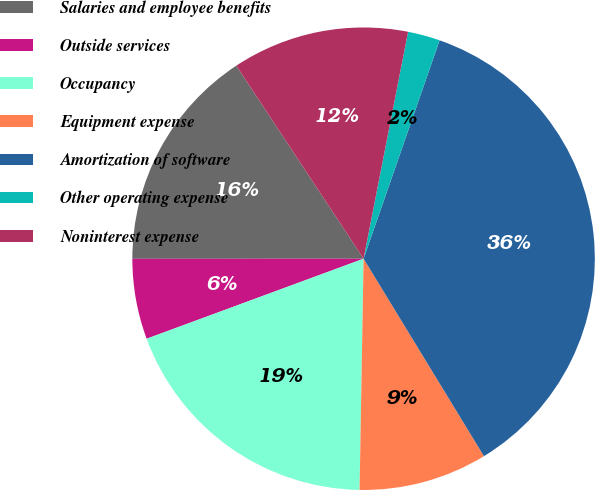Convert chart. <chart><loc_0><loc_0><loc_500><loc_500><pie_chart><fcel>Salaries and employee benefits<fcel>Outside services<fcel>Occupancy<fcel>Equipment expense<fcel>Amortization of software<fcel>Other operating expense<fcel>Noninterest expense<nl><fcel>15.73%<fcel>5.62%<fcel>19.1%<fcel>8.99%<fcel>35.96%<fcel>2.25%<fcel>12.36%<nl></chart> 